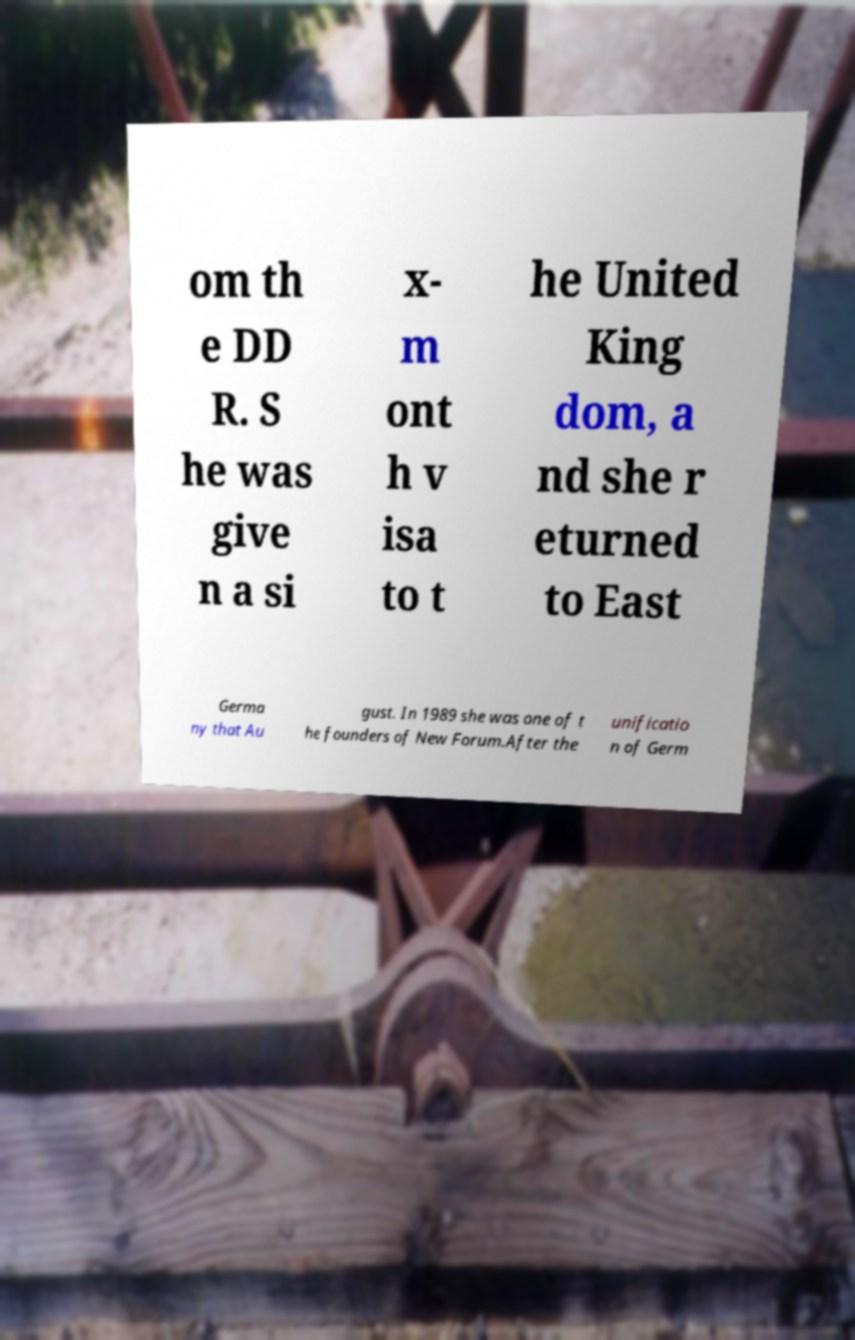For documentation purposes, I need the text within this image transcribed. Could you provide that? om th e DD R. S he was give n a si x- m ont h v isa to t he United King dom, a nd she r eturned to East Germa ny that Au gust. In 1989 she was one of t he founders of New Forum.After the unificatio n of Germ 